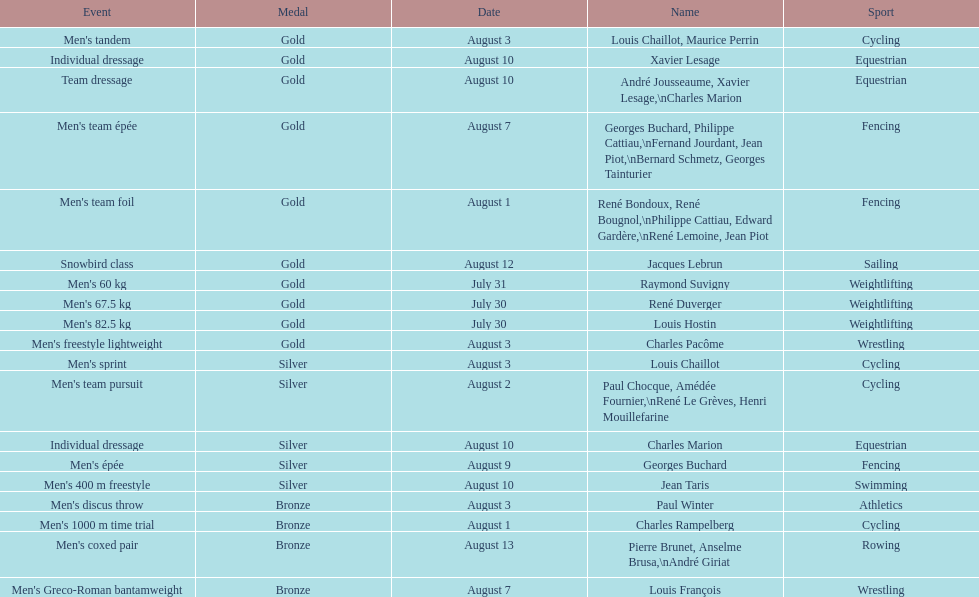What is next date that is listed after august 7th? August 1. 